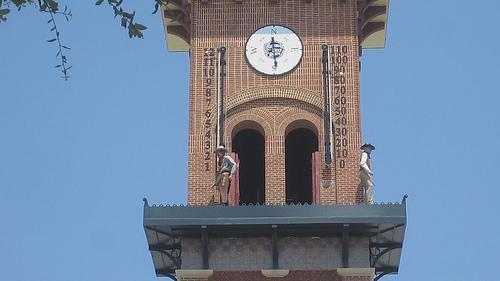How many cowboys are there?
Give a very brief answer. 2. 